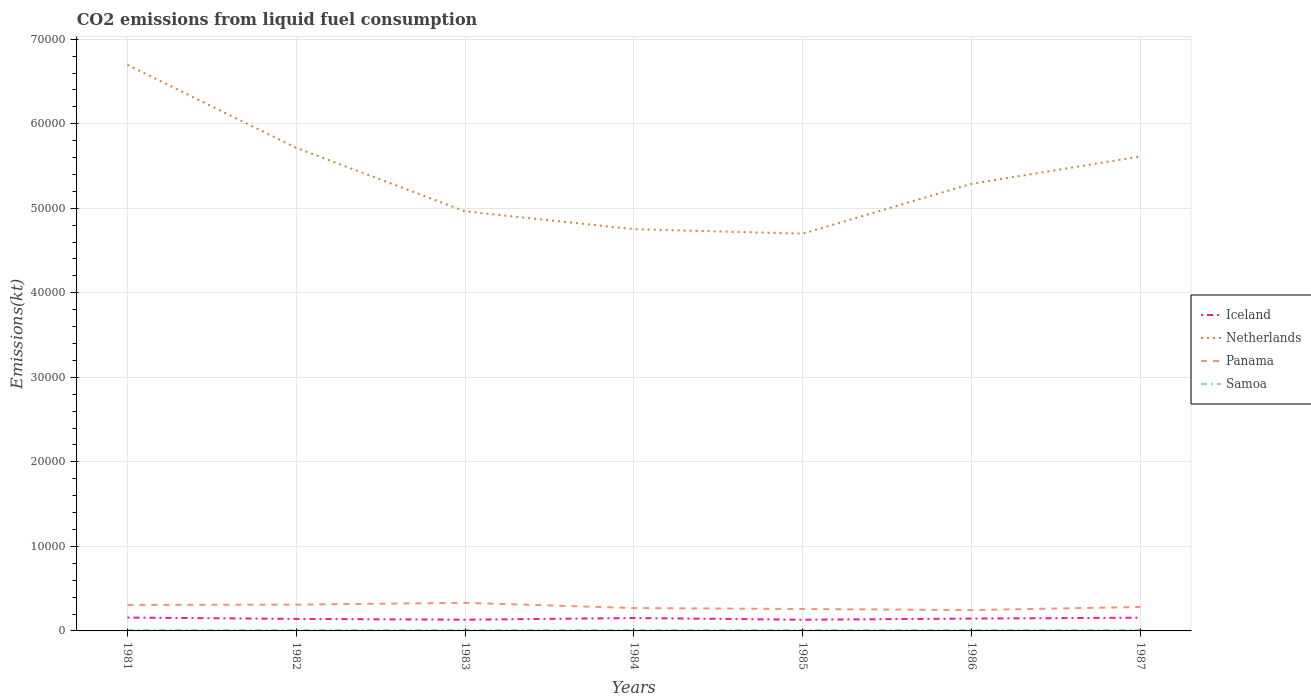How many different coloured lines are there?
Offer a very short reply. 4. Does the line corresponding to Panama intersect with the line corresponding to Netherlands?
Give a very brief answer. No. Is the number of lines equal to the number of legend labels?
Your answer should be compact. Yes. Across all years, what is the maximum amount of CO2 emitted in Panama?
Provide a succinct answer. 2464.22. What is the total amount of CO2 emitted in Netherlands in the graph?
Provide a succinct answer. -3234.29. What is the difference between the highest and the second highest amount of CO2 emitted in Netherlands?
Your answer should be compact. 2.00e+04. How many lines are there?
Provide a short and direct response. 4. Are the values on the major ticks of Y-axis written in scientific E-notation?
Keep it short and to the point. No. Does the graph contain any zero values?
Make the answer very short. No. Does the graph contain grids?
Your answer should be compact. Yes. Where does the legend appear in the graph?
Your answer should be very brief. Center right. How are the legend labels stacked?
Your answer should be compact. Vertical. What is the title of the graph?
Keep it short and to the point. CO2 emissions from liquid fuel consumption. Does "Zambia" appear as one of the legend labels in the graph?
Your answer should be very brief. No. What is the label or title of the Y-axis?
Your answer should be compact. Emissions(kt). What is the Emissions(kt) in Iceland in 1981?
Give a very brief answer. 1580.48. What is the Emissions(kt) of Netherlands in 1981?
Offer a terse response. 6.70e+04. What is the Emissions(kt) in Panama in 1981?
Offer a terse response. 3072.95. What is the Emissions(kt) in Samoa in 1981?
Keep it short and to the point. 102.68. What is the Emissions(kt) of Iceland in 1982?
Make the answer very short. 1422.8. What is the Emissions(kt) of Netherlands in 1982?
Provide a succinct answer. 5.71e+04. What is the Emissions(kt) of Panama in 1982?
Your answer should be very brief. 3109.62. What is the Emissions(kt) of Samoa in 1982?
Offer a very short reply. 113.68. What is the Emissions(kt) of Iceland in 1983?
Keep it short and to the point. 1327.45. What is the Emissions(kt) of Netherlands in 1983?
Your answer should be compact. 4.96e+04. What is the Emissions(kt) in Panama in 1983?
Your answer should be compact. 3325.97. What is the Emissions(kt) of Samoa in 1983?
Your answer should be very brief. 113.68. What is the Emissions(kt) of Iceland in 1984?
Offer a terse response. 1525.47. What is the Emissions(kt) in Netherlands in 1984?
Ensure brevity in your answer.  4.75e+04. What is the Emissions(kt) in Panama in 1984?
Offer a terse response. 2706.25. What is the Emissions(kt) in Samoa in 1984?
Ensure brevity in your answer.  113.68. What is the Emissions(kt) in Iceland in 1985?
Provide a succinct answer. 1323.79. What is the Emissions(kt) in Netherlands in 1985?
Your response must be concise. 4.70e+04. What is the Emissions(kt) of Panama in 1985?
Offer a terse response. 2592.57. What is the Emissions(kt) of Samoa in 1985?
Keep it short and to the point. 113.68. What is the Emissions(kt) in Iceland in 1986?
Provide a succinct answer. 1459.47. What is the Emissions(kt) in Netherlands in 1986?
Provide a succinct answer. 5.29e+04. What is the Emissions(kt) in Panama in 1986?
Give a very brief answer. 2464.22. What is the Emissions(kt) of Samoa in 1986?
Offer a very short reply. 113.68. What is the Emissions(kt) of Iceland in 1987?
Make the answer very short. 1565.81. What is the Emissions(kt) in Netherlands in 1987?
Offer a very short reply. 5.61e+04. What is the Emissions(kt) of Panama in 1987?
Ensure brevity in your answer.  2834.59. What is the Emissions(kt) in Samoa in 1987?
Provide a short and direct response. 113.68. Across all years, what is the maximum Emissions(kt) of Iceland?
Offer a terse response. 1580.48. Across all years, what is the maximum Emissions(kt) of Netherlands?
Give a very brief answer. 6.70e+04. Across all years, what is the maximum Emissions(kt) in Panama?
Your response must be concise. 3325.97. Across all years, what is the maximum Emissions(kt) of Samoa?
Offer a terse response. 113.68. Across all years, what is the minimum Emissions(kt) of Iceland?
Your response must be concise. 1323.79. Across all years, what is the minimum Emissions(kt) of Netherlands?
Your answer should be very brief. 4.70e+04. Across all years, what is the minimum Emissions(kt) in Panama?
Provide a short and direct response. 2464.22. Across all years, what is the minimum Emissions(kt) of Samoa?
Offer a very short reply. 102.68. What is the total Emissions(kt) of Iceland in the graph?
Ensure brevity in your answer.  1.02e+04. What is the total Emissions(kt) of Netherlands in the graph?
Give a very brief answer. 3.77e+05. What is the total Emissions(kt) of Panama in the graph?
Offer a very short reply. 2.01e+04. What is the total Emissions(kt) in Samoa in the graph?
Offer a terse response. 784.74. What is the difference between the Emissions(kt) of Iceland in 1981 and that in 1982?
Keep it short and to the point. 157.68. What is the difference between the Emissions(kt) in Netherlands in 1981 and that in 1982?
Make the answer very short. 9820.23. What is the difference between the Emissions(kt) in Panama in 1981 and that in 1982?
Offer a very short reply. -36.67. What is the difference between the Emissions(kt) of Samoa in 1981 and that in 1982?
Ensure brevity in your answer.  -11. What is the difference between the Emissions(kt) in Iceland in 1981 and that in 1983?
Make the answer very short. 253.02. What is the difference between the Emissions(kt) in Netherlands in 1981 and that in 1983?
Offer a very short reply. 1.73e+04. What is the difference between the Emissions(kt) in Panama in 1981 and that in 1983?
Offer a terse response. -253.02. What is the difference between the Emissions(kt) of Samoa in 1981 and that in 1983?
Keep it short and to the point. -11. What is the difference between the Emissions(kt) in Iceland in 1981 and that in 1984?
Provide a short and direct response. 55.01. What is the difference between the Emissions(kt) of Netherlands in 1981 and that in 1984?
Offer a terse response. 1.94e+04. What is the difference between the Emissions(kt) of Panama in 1981 and that in 1984?
Make the answer very short. 366.7. What is the difference between the Emissions(kt) of Samoa in 1981 and that in 1984?
Your answer should be very brief. -11. What is the difference between the Emissions(kt) of Iceland in 1981 and that in 1985?
Your response must be concise. 256.69. What is the difference between the Emissions(kt) of Netherlands in 1981 and that in 1985?
Your answer should be compact. 2.00e+04. What is the difference between the Emissions(kt) of Panama in 1981 and that in 1985?
Your answer should be compact. 480.38. What is the difference between the Emissions(kt) in Samoa in 1981 and that in 1985?
Your answer should be very brief. -11. What is the difference between the Emissions(kt) in Iceland in 1981 and that in 1986?
Ensure brevity in your answer.  121.01. What is the difference between the Emissions(kt) of Netherlands in 1981 and that in 1986?
Offer a very short reply. 1.41e+04. What is the difference between the Emissions(kt) of Panama in 1981 and that in 1986?
Keep it short and to the point. 608.72. What is the difference between the Emissions(kt) in Samoa in 1981 and that in 1986?
Offer a very short reply. -11. What is the difference between the Emissions(kt) in Iceland in 1981 and that in 1987?
Your answer should be very brief. 14.67. What is the difference between the Emissions(kt) in Netherlands in 1981 and that in 1987?
Your response must be concise. 1.08e+04. What is the difference between the Emissions(kt) in Panama in 1981 and that in 1987?
Provide a succinct answer. 238.35. What is the difference between the Emissions(kt) in Samoa in 1981 and that in 1987?
Offer a very short reply. -11. What is the difference between the Emissions(kt) of Iceland in 1982 and that in 1983?
Your response must be concise. 95.34. What is the difference between the Emissions(kt) of Netherlands in 1982 and that in 1983?
Provide a succinct answer. 7510.02. What is the difference between the Emissions(kt) in Panama in 1982 and that in 1983?
Offer a terse response. -216.35. What is the difference between the Emissions(kt) in Iceland in 1982 and that in 1984?
Offer a very short reply. -102.68. What is the difference between the Emissions(kt) in Netherlands in 1982 and that in 1984?
Give a very brief answer. 9622.21. What is the difference between the Emissions(kt) of Panama in 1982 and that in 1984?
Provide a short and direct response. 403.37. What is the difference between the Emissions(kt) in Iceland in 1982 and that in 1985?
Make the answer very short. 99.01. What is the difference between the Emissions(kt) of Netherlands in 1982 and that in 1985?
Your response must be concise. 1.02e+04. What is the difference between the Emissions(kt) in Panama in 1982 and that in 1985?
Your response must be concise. 517.05. What is the difference between the Emissions(kt) in Samoa in 1982 and that in 1985?
Your answer should be very brief. 0. What is the difference between the Emissions(kt) in Iceland in 1982 and that in 1986?
Your answer should be compact. -36.67. What is the difference between the Emissions(kt) of Netherlands in 1982 and that in 1986?
Give a very brief answer. 4253.72. What is the difference between the Emissions(kt) in Panama in 1982 and that in 1986?
Ensure brevity in your answer.  645.39. What is the difference between the Emissions(kt) of Iceland in 1982 and that in 1987?
Your answer should be very brief. -143.01. What is the difference between the Emissions(kt) of Netherlands in 1982 and that in 1987?
Ensure brevity in your answer.  1019.43. What is the difference between the Emissions(kt) of Panama in 1982 and that in 1987?
Make the answer very short. 275.02. What is the difference between the Emissions(kt) in Iceland in 1983 and that in 1984?
Provide a short and direct response. -198.02. What is the difference between the Emissions(kt) of Netherlands in 1983 and that in 1984?
Your response must be concise. 2112.19. What is the difference between the Emissions(kt) of Panama in 1983 and that in 1984?
Make the answer very short. 619.72. What is the difference between the Emissions(kt) of Samoa in 1983 and that in 1984?
Provide a short and direct response. 0. What is the difference between the Emissions(kt) of Iceland in 1983 and that in 1985?
Keep it short and to the point. 3.67. What is the difference between the Emissions(kt) in Netherlands in 1983 and that in 1985?
Provide a succinct answer. 2640.24. What is the difference between the Emissions(kt) in Panama in 1983 and that in 1985?
Offer a very short reply. 733.4. What is the difference between the Emissions(kt) in Samoa in 1983 and that in 1985?
Provide a short and direct response. 0. What is the difference between the Emissions(kt) in Iceland in 1983 and that in 1986?
Ensure brevity in your answer.  -132.01. What is the difference between the Emissions(kt) of Netherlands in 1983 and that in 1986?
Your answer should be very brief. -3256.3. What is the difference between the Emissions(kt) in Panama in 1983 and that in 1986?
Ensure brevity in your answer.  861.75. What is the difference between the Emissions(kt) of Iceland in 1983 and that in 1987?
Make the answer very short. -238.35. What is the difference between the Emissions(kt) in Netherlands in 1983 and that in 1987?
Your response must be concise. -6490.59. What is the difference between the Emissions(kt) of Panama in 1983 and that in 1987?
Offer a terse response. 491.38. What is the difference between the Emissions(kt) in Samoa in 1983 and that in 1987?
Your answer should be compact. 0. What is the difference between the Emissions(kt) in Iceland in 1984 and that in 1985?
Offer a terse response. 201.69. What is the difference between the Emissions(kt) in Netherlands in 1984 and that in 1985?
Your answer should be compact. 528.05. What is the difference between the Emissions(kt) in Panama in 1984 and that in 1985?
Offer a very short reply. 113.68. What is the difference between the Emissions(kt) of Samoa in 1984 and that in 1985?
Your answer should be compact. 0. What is the difference between the Emissions(kt) in Iceland in 1984 and that in 1986?
Ensure brevity in your answer.  66.01. What is the difference between the Emissions(kt) in Netherlands in 1984 and that in 1986?
Provide a succinct answer. -5368.49. What is the difference between the Emissions(kt) in Panama in 1984 and that in 1986?
Your answer should be compact. 242.02. What is the difference between the Emissions(kt) of Samoa in 1984 and that in 1986?
Offer a terse response. 0. What is the difference between the Emissions(kt) in Iceland in 1984 and that in 1987?
Give a very brief answer. -40.34. What is the difference between the Emissions(kt) in Netherlands in 1984 and that in 1987?
Make the answer very short. -8602.78. What is the difference between the Emissions(kt) in Panama in 1984 and that in 1987?
Your answer should be compact. -128.34. What is the difference between the Emissions(kt) in Samoa in 1984 and that in 1987?
Ensure brevity in your answer.  0. What is the difference between the Emissions(kt) in Iceland in 1985 and that in 1986?
Provide a short and direct response. -135.68. What is the difference between the Emissions(kt) in Netherlands in 1985 and that in 1986?
Offer a very short reply. -5896.54. What is the difference between the Emissions(kt) in Panama in 1985 and that in 1986?
Ensure brevity in your answer.  128.34. What is the difference between the Emissions(kt) of Iceland in 1985 and that in 1987?
Keep it short and to the point. -242.02. What is the difference between the Emissions(kt) of Netherlands in 1985 and that in 1987?
Your response must be concise. -9130.83. What is the difference between the Emissions(kt) of Panama in 1985 and that in 1987?
Keep it short and to the point. -242.02. What is the difference between the Emissions(kt) of Iceland in 1986 and that in 1987?
Your answer should be compact. -106.34. What is the difference between the Emissions(kt) in Netherlands in 1986 and that in 1987?
Your response must be concise. -3234.29. What is the difference between the Emissions(kt) of Panama in 1986 and that in 1987?
Your response must be concise. -370.37. What is the difference between the Emissions(kt) of Samoa in 1986 and that in 1987?
Make the answer very short. 0. What is the difference between the Emissions(kt) of Iceland in 1981 and the Emissions(kt) of Netherlands in 1982?
Your answer should be very brief. -5.56e+04. What is the difference between the Emissions(kt) of Iceland in 1981 and the Emissions(kt) of Panama in 1982?
Keep it short and to the point. -1529.14. What is the difference between the Emissions(kt) in Iceland in 1981 and the Emissions(kt) in Samoa in 1982?
Offer a terse response. 1466.8. What is the difference between the Emissions(kt) of Netherlands in 1981 and the Emissions(kt) of Panama in 1982?
Keep it short and to the point. 6.39e+04. What is the difference between the Emissions(kt) of Netherlands in 1981 and the Emissions(kt) of Samoa in 1982?
Provide a succinct answer. 6.69e+04. What is the difference between the Emissions(kt) of Panama in 1981 and the Emissions(kt) of Samoa in 1982?
Offer a terse response. 2959.27. What is the difference between the Emissions(kt) of Iceland in 1981 and the Emissions(kt) of Netherlands in 1983?
Ensure brevity in your answer.  -4.81e+04. What is the difference between the Emissions(kt) in Iceland in 1981 and the Emissions(kt) in Panama in 1983?
Make the answer very short. -1745.49. What is the difference between the Emissions(kt) in Iceland in 1981 and the Emissions(kt) in Samoa in 1983?
Ensure brevity in your answer.  1466.8. What is the difference between the Emissions(kt) of Netherlands in 1981 and the Emissions(kt) of Panama in 1983?
Your answer should be very brief. 6.36e+04. What is the difference between the Emissions(kt) of Netherlands in 1981 and the Emissions(kt) of Samoa in 1983?
Ensure brevity in your answer.  6.69e+04. What is the difference between the Emissions(kt) in Panama in 1981 and the Emissions(kt) in Samoa in 1983?
Ensure brevity in your answer.  2959.27. What is the difference between the Emissions(kt) in Iceland in 1981 and the Emissions(kt) in Netherlands in 1984?
Give a very brief answer. -4.59e+04. What is the difference between the Emissions(kt) of Iceland in 1981 and the Emissions(kt) of Panama in 1984?
Ensure brevity in your answer.  -1125.77. What is the difference between the Emissions(kt) in Iceland in 1981 and the Emissions(kt) in Samoa in 1984?
Ensure brevity in your answer.  1466.8. What is the difference between the Emissions(kt) in Netherlands in 1981 and the Emissions(kt) in Panama in 1984?
Offer a terse response. 6.43e+04. What is the difference between the Emissions(kt) in Netherlands in 1981 and the Emissions(kt) in Samoa in 1984?
Offer a terse response. 6.69e+04. What is the difference between the Emissions(kt) of Panama in 1981 and the Emissions(kt) of Samoa in 1984?
Offer a very short reply. 2959.27. What is the difference between the Emissions(kt) in Iceland in 1981 and the Emissions(kt) in Netherlands in 1985?
Keep it short and to the point. -4.54e+04. What is the difference between the Emissions(kt) of Iceland in 1981 and the Emissions(kt) of Panama in 1985?
Provide a succinct answer. -1012.09. What is the difference between the Emissions(kt) in Iceland in 1981 and the Emissions(kt) in Samoa in 1985?
Give a very brief answer. 1466.8. What is the difference between the Emissions(kt) of Netherlands in 1981 and the Emissions(kt) of Panama in 1985?
Provide a succinct answer. 6.44e+04. What is the difference between the Emissions(kt) in Netherlands in 1981 and the Emissions(kt) in Samoa in 1985?
Give a very brief answer. 6.69e+04. What is the difference between the Emissions(kt) in Panama in 1981 and the Emissions(kt) in Samoa in 1985?
Make the answer very short. 2959.27. What is the difference between the Emissions(kt) of Iceland in 1981 and the Emissions(kt) of Netherlands in 1986?
Your answer should be very brief. -5.13e+04. What is the difference between the Emissions(kt) in Iceland in 1981 and the Emissions(kt) in Panama in 1986?
Offer a terse response. -883.75. What is the difference between the Emissions(kt) of Iceland in 1981 and the Emissions(kt) of Samoa in 1986?
Provide a short and direct response. 1466.8. What is the difference between the Emissions(kt) in Netherlands in 1981 and the Emissions(kt) in Panama in 1986?
Your answer should be very brief. 6.45e+04. What is the difference between the Emissions(kt) in Netherlands in 1981 and the Emissions(kt) in Samoa in 1986?
Make the answer very short. 6.69e+04. What is the difference between the Emissions(kt) of Panama in 1981 and the Emissions(kt) of Samoa in 1986?
Ensure brevity in your answer.  2959.27. What is the difference between the Emissions(kt) in Iceland in 1981 and the Emissions(kt) in Netherlands in 1987?
Provide a succinct answer. -5.45e+04. What is the difference between the Emissions(kt) of Iceland in 1981 and the Emissions(kt) of Panama in 1987?
Your answer should be very brief. -1254.11. What is the difference between the Emissions(kt) in Iceland in 1981 and the Emissions(kt) in Samoa in 1987?
Provide a succinct answer. 1466.8. What is the difference between the Emissions(kt) of Netherlands in 1981 and the Emissions(kt) of Panama in 1987?
Your answer should be compact. 6.41e+04. What is the difference between the Emissions(kt) in Netherlands in 1981 and the Emissions(kt) in Samoa in 1987?
Keep it short and to the point. 6.69e+04. What is the difference between the Emissions(kt) in Panama in 1981 and the Emissions(kt) in Samoa in 1987?
Give a very brief answer. 2959.27. What is the difference between the Emissions(kt) of Iceland in 1982 and the Emissions(kt) of Netherlands in 1983?
Provide a succinct answer. -4.82e+04. What is the difference between the Emissions(kt) of Iceland in 1982 and the Emissions(kt) of Panama in 1983?
Provide a succinct answer. -1903.17. What is the difference between the Emissions(kt) in Iceland in 1982 and the Emissions(kt) in Samoa in 1983?
Your answer should be very brief. 1309.12. What is the difference between the Emissions(kt) of Netherlands in 1982 and the Emissions(kt) of Panama in 1983?
Make the answer very short. 5.38e+04. What is the difference between the Emissions(kt) in Netherlands in 1982 and the Emissions(kt) in Samoa in 1983?
Provide a short and direct response. 5.70e+04. What is the difference between the Emissions(kt) in Panama in 1982 and the Emissions(kt) in Samoa in 1983?
Make the answer very short. 2995.94. What is the difference between the Emissions(kt) of Iceland in 1982 and the Emissions(kt) of Netherlands in 1984?
Your response must be concise. -4.61e+04. What is the difference between the Emissions(kt) in Iceland in 1982 and the Emissions(kt) in Panama in 1984?
Keep it short and to the point. -1283.45. What is the difference between the Emissions(kt) in Iceland in 1982 and the Emissions(kt) in Samoa in 1984?
Provide a short and direct response. 1309.12. What is the difference between the Emissions(kt) in Netherlands in 1982 and the Emissions(kt) in Panama in 1984?
Give a very brief answer. 5.44e+04. What is the difference between the Emissions(kt) in Netherlands in 1982 and the Emissions(kt) in Samoa in 1984?
Provide a short and direct response. 5.70e+04. What is the difference between the Emissions(kt) in Panama in 1982 and the Emissions(kt) in Samoa in 1984?
Make the answer very short. 2995.94. What is the difference between the Emissions(kt) in Iceland in 1982 and the Emissions(kt) in Netherlands in 1985?
Your answer should be compact. -4.56e+04. What is the difference between the Emissions(kt) of Iceland in 1982 and the Emissions(kt) of Panama in 1985?
Provide a succinct answer. -1169.77. What is the difference between the Emissions(kt) in Iceland in 1982 and the Emissions(kt) in Samoa in 1985?
Offer a very short reply. 1309.12. What is the difference between the Emissions(kt) in Netherlands in 1982 and the Emissions(kt) in Panama in 1985?
Make the answer very short. 5.46e+04. What is the difference between the Emissions(kt) in Netherlands in 1982 and the Emissions(kt) in Samoa in 1985?
Offer a terse response. 5.70e+04. What is the difference between the Emissions(kt) in Panama in 1982 and the Emissions(kt) in Samoa in 1985?
Keep it short and to the point. 2995.94. What is the difference between the Emissions(kt) in Iceland in 1982 and the Emissions(kt) in Netherlands in 1986?
Your answer should be very brief. -5.15e+04. What is the difference between the Emissions(kt) of Iceland in 1982 and the Emissions(kt) of Panama in 1986?
Ensure brevity in your answer.  -1041.43. What is the difference between the Emissions(kt) of Iceland in 1982 and the Emissions(kt) of Samoa in 1986?
Your answer should be compact. 1309.12. What is the difference between the Emissions(kt) in Netherlands in 1982 and the Emissions(kt) in Panama in 1986?
Your answer should be compact. 5.47e+04. What is the difference between the Emissions(kt) of Netherlands in 1982 and the Emissions(kt) of Samoa in 1986?
Provide a succinct answer. 5.70e+04. What is the difference between the Emissions(kt) of Panama in 1982 and the Emissions(kt) of Samoa in 1986?
Your response must be concise. 2995.94. What is the difference between the Emissions(kt) in Iceland in 1982 and the Emissions(kt) in Netherlands in 1987?
Your answer should be very brief. -5.47e+04. What is the difference between the Emissions(kt) in Iceland in 1982 and the Emissions(kt) in Panama in 1987?
Your answer should be compact. -1411.8. What is the difference between the Emissions(kt) in Iceland in 1982 and the Emissions(kt) in Samoa in 1987?
Your answer should be very brief. 1309.12. What is the difference between the Emissions(kt) of Netherlands in 1982 and the Emissions(kt) of Panama in 1987?
Provide a succinct answer. 5.43e+04. What is the difference between the Emissions(kt) in Netherlands in 1982 and the Emissions(kt) in Samoa in 1987?
Your answer should be very brief. 5.70e+04. What is the difference between the Emissions(kt) of Panama in 1982 and the Emissions(kt) of Samoa in 1987?
Provide a short and direct response. 2995.94. What is the difference between the Emissions(kt) in Iceland in 1983 and the Emissions(kt) in Netherlands in 1984?
Make the answer very short. -4.62e+04. What is the difference between the Emissions(kt) of Iceland in 1983 and the Emissions(kt) of Panama in 1984?
Provide a short and direct response. -1378.79. What is the difference between the Emissions(kt) of Iceland in 1983 and the Emissions(kt) of Samoa in 1984?
Your answer should be very brief. 1213.78. What is the difference between the Emissions(kt) of Netherlands in 1983 and the Emissions(kt) of Panama in 1984?
Make the answer very short. 4.69e+04. What is the difference between the Emissions(kt) in Netherlands in 1983 and the Emissions(kt) in Samoa in 1984?
Provide a succinct answer. 4.95e+04. What is the difference between the Emissions(kt) of Panama in 1983 and the Emissions(kt) of Samoa in 1984?
Your response must be concise. 3212.29. What is the difference between the Emissions(kt) of Iceland in 1983 and the Emissions(kt) of Netherlands in 1985?
Keep it short and to the point. -4.57e+04. What is the difference between the Emissions(kt) in Iceland in 1983 and the Emissions(kt) in Panama in 1985?
Provide a short and direct response. -1265.12. What is the difference between the Emissions(kt) of Iceland in 1983 and the Emissions(kt) of Samoa in 1985?
Make the answer very short. 1213.78. What is the difference between the Emissions(kt) in Netherlands in 1983 and the Emissions(kt) in Panama in 1985?
Make the answer very short. 4.70e+04. What is the difference between the Emissions(kt) in Netherlands in 1983 and the Emissions(kt) in Samoa in 1985?
Keep it short and to the point. 4.95e+04. What is the difference between the Emissions(kt) of Panama in 1983 and the Emissions(kt) of Samoa in 1985?
Make the answer very short. 3212.29. What is the difference between the Emissions(kt) of Iceland in 1983 and the Emissions(kt) of Netherlands in 1986?
Ensure brevity in your answer.  -5.16e+04. What is the difference between the Emissions(kt) in Iceland in 1983 and the Emissions(kt) in Panama in 1986?
Ensure brevity in your answer.  -1136.77. What is the difference between the Emissions(kt) in Iceland in 1983 and the Emissions(kt) in Samoa in 1986?
Your answer should be compact. 1213.78. What is the difference between the Emissions(kt) in Netherlands in 1983 and the Emissions(kt) in Panama in 1986?
Your answer should be compact. 4.72e+04. What is the difference between the Emissions(kt) of Netherlands in 1983 and the Emissions(kt) of Samoa in 1986?
Your answer should be compact. 4.95e+04. What is the difference between the Emissions(kt) in Panama in 1983 and the Emissions(kt) in Samoa in 1986?
Your response must be concise. 3212.29. What is the difference between the Emissions(kt) in Iceland in 1983 and the Emissions(kt) in Netherlands in 1987?
Ensure brevity in your answer.  -5.48e+04. What is the difference between the Emissions(kt) of Iceland in 1983 and the Emissions(kt) of Panama in 1987?
Offer a terse response. -1507.14. What is the difference between the Emissions(kt) in Iceland in 1983 and the Emissions(kt) in Samoa in 1987?
Provide a short and direct response. 1213.78. What is the difference between the Emissions(kt) in Netherlands in 1983 and the Emissions(kt) in Panama in 1987?
Keep it short and to the point. 4.68e+04. What is the difference between the Emissions(kt) in Netherlands in 1983 and the Emissions(kt) in Samoa in 1987?
Your response must be concise. 4.95e+04. What is the difference between the Emissions(kt) of Panama in 1983 and the Emissions(kt) of Samoa in 1987?
Offer a very short reply. 3212.29. What is the difference between the Emissions(kt) of Iceland in 1984 and the Emissions(kt) of Netherlands in 1985?
Offer a very short reply. -4.55e+04. What is the difference between the Emissions(kt) in Iceland in 1984 and the Emissions(kt) in Panama in 1985?
Ensure brevity in your answer.  -1067.1. What is the difference between the Emissions(kt) in Iceland in 1984 and the Emissions(kt) in Samoa in 1985?
Your answer should be compact. 1411.8. What is the difference between the Emissions(kt) in Netherlands in 1984 and the Emissions(kt) in Panama in 1985?
Keep it short and to the point. 4.49e+04. What is the difference between the Emissions(kt) in Netherlands in 1984 and the Emissions(kt) in Samoa in 1985?
Your answer should be compact. 4.74e+04. What is the difference between the Emissions(kt) in Panama in 1984 and the Emissions(kt) in Samoa in 1985?
Offer a terse response. 2592.57. What is the difference between the Emissions(kt) of Iceland in 1984 and the Emissions(kt) of Netherlands in 1986?
Give a very brief answer. -5.14e+04. What is the difference between the Emissions(kt) in Iceland in 1984 and the Emissions(kt) in Panama in 1986?
Ensure brevity in your answer.  -938.75. What is the difference between the Emissions(kt) in Iceland in 1984 and the Emissions(kt) in Samoa in 1986?
Your answer should be compact. 1411.8. What is the difference between the Emissions(kt) of Netherlands in 1984 and the Emissions(kt) of Panama in 1986?
Offer a terse response. 4.51e+04. What is the difference between the Emissions(kt) of Netherlands in 1984 and the Emissions(kt) of Samoa in 1986?
Offer a very short reply. 4.74e+04. What is the difference between the Emissions(kt) in Panama in 1984 and the Emissions(kt) in Samoa in 1986?
Ensure brevity in your answer.  2592.57. What is the difference between the Emissions(kt) in Iceland in 1984 and the Emissions(kt) in Netherlands in 1987?
Your answer should be compact. -5.46e+04. What is the difference between the Emissions(kt) in Iceland in 1984 and the Emissions(kt) in Panama in 1987?
Provide a succinct answer. -1309.12. What is the difference between the Emissions(kt) of Iceland in 1984 and the Emissions(kt) of Samoa in 1987?
Your response must be concise. 1411.8. What is the difference between the Emissions(kt) in Netherlands in 1984 and the Emissions(kt) in Panama in 1987?
Offer a terse response. 4.47e+04. What is the difference between the Emissions(kt) in Netherlands in 1984 and the Emissions(kt) in Samoa in 1987?
Provide a succinct answer. 4.74e+04. What is the difference between the Emissions(kt) in Panama in 1984 and the Emissions(kt) in Samoa in 1987?
Offer a very short reply. 2592.57. What is the difference between the Emissions(kt) of Iceland in 1985 and the Emissions(kt) of Netherlands in 1986?
Make the answer very short. -5.16e+04. What is the difference between the Emissions(kt) of Iceland in 1985 and the Emissions(kt) of Panama in 1986?
Your answer should be compact. -1140.44. What is the difference between the Emissions(kt) in Iceland in 1985 and the Emissions(kt) in Samoa in 1986?
Provide a succinct answer. 1210.11. What is the difference between the Emissions(kt) of Netherlands in 1985 and the Emissions(kt) of Panama in 1986?
Ensure brevity in your answer.  4.45e+04. What is the difference between the Emissions(kt) of Netherlands in 1985 and the Emissions(kt) of Samoa in 1986?
Provide a succinct answer. 4.69e+04. What is the difference between the Emissions(kt) in Panama in 1985 and the Emissions(kt) in Samoa in 1986?
Make the answer very short. 2478.89. What is the difference between the Emissions(kt) of Iceland in 1985 and the Emissions(kt) of Netherlands in 1987?
Your answer should be very brief. -5.48e+04. What is the difference between the Emissions(kt) in Iceland in 1985 and the Emissions(kt) in Panama in 1987?
Keep it short and to the point. -1510.8. What is the difference between the Emissions(kt) of Iceland in 1985 and the Emissions(kt) of Samoa in 1987?
Make the answer very short. 1210.11. What is the difference between the Emissions(kt) of Netherlands in 1985 and the Emissions(kt) of Panama in 1987?
Offer a very short reply. 4.42e+04. What is the difference between the Emissions(kt) in Netherlands in 1985 and the Emissions(kt) in Samoa in 1987?
Ensure brevity in your answer.  4.69e+04. What is the difference between the Emissions(kt) of Panama in 1985 and the Emissions(kt) of Samoa in 1987?
Your answer should be compact. 2478.89. What is the difference between the Emissions(kt) of Iceland in 1986 and the Emissions(kt) of Netherlands in 1987?
Your response must be concise. -5.47e+04. What is the difference between the Emissions(kt) in Iceland in 1986 and the Emissions(kt) in Panama in 1987?
Provide a short and direct response. -1375.12. What is the difference between the Emissions(kt) of Iceland in 1986 and the Emissions(kt) of Samoa in 1987?
Give a very brief answer. 1345.79. What is the difference between the Emissions(kt) of Netherlands in 1986 and the Emissions(kt) of Panama in 1987?
Your answer should be compact. 5.01e+04. What is the difference between the Emissions(kt) of Netherlands in 1986 and the Emissions(kt) of Samoa in 1987?
Give a very brief answer. 5.28e+04. What is the difference between the Emissions(kt) in Panama in 1986 and the Emissions(kt) in Samoa in 1987?
Ensure brevity in your answer.  2350.55. What is the average Emissions(kt) in Iceland per year?
Offer a very short reply. 1457.89. What is the average Emissions(kt) of Netherlands per year?
Provide a succinct answer. 5.39e+04. What is the average Emissions(kt) in Panama per year?
Your answer should be very brief. 2872.31. What is the average Emissions(kt) of Samoa per year?
Your response must be concise. 112.11. In the year 1981, what is the difference between the Emissions(kt) in Iceland and Emissions(kt) in Netherlands?
Offer a terse response. -6.54e+04. In the year 1981, what is the difference between the Emissions(kt) of Iceland and Emissions(kt) of Panama?
Your answer should be very brief. -1492.47. In the year 1981, what is the difference between the Emissions(kt) in Iceland and Emissions(kt) in Samoa?
Make the answer very short. 1477.8. In the year 1981, what is the difference between the Emissions(kt) in Netherlands and Emissions(kt) in Panama?
Keep it short and to the point. 6.39e+04. In the year 1981, what is the difference between the Emissions(kt) of Netherlands and Emissions(kt) of Samoa?
Make the answer very short. 6.69e+04. In the year 1981, what is the difference between the Emissions(kt) of Panama and Emissions(kt) of Samoa?
Provide a short and direct response. 2970.27. In the year 1982, what is the difference between the Emissions(kt) in Iceland and Emissions(kt) in Netherlands?
Ensure brevity in your answer.  -5.57e+04. In the year 1982, what is the difference between the Emissions(kt) of Iceland and Emissions(kt) of Panama?
Your answer should be very brief. -1686.82. In the year 1982, what is the difference between the Emissions(kt) of Iceland and Emissions(kt) of Samoa?
Give a very brief answer. 1309.12. In the year 1982, what is the difference between the Emissions(kt) in Netherlands and Emissions(kt) in Panama?
Keep it short and to the point. 5.40e+04. In the year 1982, what is the difference between the Emissions(kt) of Netherlands and Emissions(kt) of Samoa?
Your response must be concise. 5.70e+04. In the year 1982, what is the difference between the Emissions(kt) in Panama and Emissions(kt) in Samoa?
Your response must be concise. 2995.94. In the year 1983, what is the difference between the Emissions(kt) of Iceland and Emissions(kt) of Netherlands?
Your response must be concise. -4.83e+04. In the year 1983, what is the difference between the Emissions(kt) of Iceland and Emissions(kt) of Panama?
Provide a succinct answer. -1998.52. In the year 1983, what is the difference between the Emissions(kt) in Iceland and Emissions(kt) in Samoa?
Provide a short and direct response. 1213.78. In the year 1983, what is the difference between the Emissions(kt) of Netherlands and Emissions(kt) of Panama?
Keep it short and to the point. 4.63e+04. In the year 1983, what is the difference between the Emissions(kt) of Netherlands and Emissions(kt) of Samoa?
Provide a succinct answer. 4.95e+04. In the year 1983, what is the difference between the Emissions(kt) of Panama and Emissions(kt) of Samoa?
Your answer should be compact. 3212.29. In the year 1984, what is the difference between the Emissions(kt) in Iceland and Emissions(kt) in Netherlands?
Make the answer very short. -4.60e+04. In the year 1984, what is the difference between the Emissions(kt) of Iceland and Emissions(kt) of Panama?
Offer a terse response. -1180.77. In the year 1984, what is the difference between the Emissions(kt) of Iceland and Emissions(kt) of Samoa?
Keep it short and to the point. 1411.8. In the year 1984, what is the difference between the Emissions(kt) of Netherlands and Emissions(kt) of Panama?
Keep it short and to the point. 4.48e+04. In the year 1984, what is the difference between the Emissions(kt) of Netherlands and Emissions(kt) of Samoa?
Your response must be concise. 4.74e+04. In the year 1984, what is the difference between the Emissions(kt) of Panama and Emissions(kt) of Samoa?
Your answer should be compact. 2592.57. In the year 1985, what is the difference between the Emissions(kt) in Iceland and Emissions(kt) in Netherlands?
Offer a very short reply. -4.57e+04. In the year 1985, what is the difference between the Emissions(kt) of Iceland and Emissions(kt) of Panama?
Your response must be concise. -1268.78. In the year 1985, what is the difference between the Emissions(kt) in Iceland and Emissions(kt) in Samoa?
Offer a terse response. 1210.11. In the year 1985, what is the difference between the Emissions(kt) of Netherlands and Emissions(kt) of Panama?
Provide a short and direct response. 4.44e+04. In the year 1985, what is the difference between the Emissions(kt) in Netherlands and Emissions(kt) in Samoa?
Your response must be concise. 4.69e+04. In the year 1985, what is the difference between the Emissions(kt) in Panama and Emissions(kt) in Samoa?
Your answer should be compact. 2478.89. In the year 1986, what is the difference between the Emissions(kt) in Iceland and Emissions(kt) in Netherlands?
Make the answer very short. -5.14e+04. In the year 1986, what is the difference between the Emissions(kt) in Iceland and Emissions(kt) in Panama?
Provide a succinct answer. -1004.76. In the year 1986, what is the difference between the Emissions(kt) in Iceland and Emissions(kt) in Samoa?
Offer a very short reply. 1345.79. In the year 1986, what is the difference between the Emissions(kt) in Netherlands and Emissions(kt) in Panama?
Provide a short and direct response. 5.04e+04. In the year 1986, what is the difference between the Emissions(kt) in Netherlands and Emissions(kt) in Samoa?
Your response must be concise. 5.28e+04. In the year 1986, what is the difference between the Emissions(kt) in Panama and Emissions(kt) in Samoa?
Your response must be concise. 2350.55. In the year 1987, what is the difference between the Emissions(kt) in Iceland and Emissions(kt) in Netherlands?
Make the answer very short. -5.46e+04. In the year 1987, what is the difference between the Emissions(kt) in Iceland and Emissions(kt) in Panama?
Offer a terse response. -1268.78. In the year 1987, what is the difference between the Emissions(kt) of Iceland and Emissions(kt) of Samoa?
Provide a short and direct response. 1452.13. In the year 1987, what is the difference between the Emissions(kt) in Netherlands and Emissions(kt) in Panama?
Provide a short and direct response. 5.33e+04. In the year 1987, what is the difference between the Emissions(kt) in Netherlands and Emissions(kt) in Samoa?
Ensure brevity in your answer.  5.60e+04. In the year 1987, what is the difference between the Emissions(kt) in Panama and Emissions(kt) in Samoa?
Make the answer very short. 2720.91. What is the ratio of the Emissions(kt) of Iceland in 1981 to that in 1982?
Provide a short and direct response. 1.11. What is the ratio of the Emissions(kt) in Netherlands in 1981 to that in 1982?
Your response must be concise. 1.17. What is the ratio of the Emissions(kt) of Panama in 1981 to that in 1982?
Ensure brevity in your answer.  0.99. What is the ratio of the Emissions(kt) of Samoa in 1981 to that in 1982?
Provide a succinct answer. 0.9. What is the ratio of the Emissions(kt) in Iceland in 1981 to that in 1983?
Provide a short and direct response. 1.19. What is the ratio of the Emissions(kt) in Netherlands in 1981 to that in 1983?
Ensure brevity in your answer.  1.35. What is the ratio of the Emissions(kt) in Panama in 1981 to that in 1983?
Make the answer very short. 0.92. What is the ratio of the Emissions(kt) of Samoa in 1981 to that in 1983?
Provide a short and direct response. 0.9. What is the ratio of the Emissions(kt) of Iceland in 1981 to that in 1984?
Offer a very short reply. 1.04. What is the ratio of the Emissions(kt) of Netherlands in 1981 to that in 1984?
Your answer should be compact. 1.41. What is the ratio of the Emissions(kt) of Panama in 1981 to that in 1984?
Ensure brevity in your answer.  1.14. What is the ratio of the Emissions(kt) in Samoa in 1981 to that in 1984?
Your response must be concise. 0.9. What is the ratio of the Emissions(kt) in Iceland in 1981 to that in 1985?
Make the answer very short. 1.19. What is the ratio of the Emissions(kt) of Netherlands in 1981 to that in 1985?
Provide a short and direct response. 1.42. What is the ratio of the Emissions(kt) in Panama in 1981 to that in 1985?
Your answer should be compact. 1.19. What is the ratio of the Emissions(kt) of Samoa in 1981 to that in 1985?
Offer a very short reply. 0.9. What is the ratio of the Emissions(kt) in Iceland in 1981 to that in 1986?
Give a very brief answer. 1.08. What is the ratio of the Emissions(kt) of Netherlands in 1981 to that in 1986?
Make the answer very short. 1.27. What is the ratio of the Emissions(kt) in Panama in 1981 to that in 1986?
Provide a short and direct response. 1.25. What is the ratio of the Emissions(kt) of Samoa in 1981 to that in 1986?
Make the answer very short. 0.9. What is the ratio of the Emissions(kt) of Iceland in 1981 to that in 1987?
Provide a short and direct response. 1.01. What is the ratio of the Emissions(kt) of Netherlands in 1981 to that in 1987?
Offer a very short reply. 1.19. What is the ratio of the Emissions(kt) in Panama in 1981 to that in 1987?
Your answer should be very brief. 1.08. What is the ratio of the Emissions(kt) in Samoa in 1981 to that in 1987?
Your response must be concise. 0.9. What is the ratio of the Emissions(kt) in Iceland in 1982 to that in 1983?
Your response must be concise. 1.07. What is the ratio of the Emissions(kt) in Netherlands in 1982 to that in 1983?
Your answer should be very brief. 1.15. What is the ratio of the Emissions(kt) in Panama in 1982 to that in 1983?
Make the answer very short. 0.94. What is the ratio of the Emissions(kt) in Samoa in 1982 to that in 1983?
Offer a terse response. 1. What is the ratio of the Emissions(kt) of Iceland in 1982 to that in 1984?
Ensure brevity in your answer.  0.93. What is the ratio of the Emissions(kt) of Netherlands in 1982 to that in 1984?
Your response must be concise. 1.2. What is the ratio of the Emissions(kt) in Panama in 1982 to that in 1984?
Make the answer very short. 1.15. What is the ratio of the Emissions(kt) of Samoa in 1982 to that in 1984?
Keep it short and to the point. 1. What is the ratio of the Emissions(kt) of Iceland in 1982 to that in 1985?
Ensure brevity in your answer.  1.07. What is the ratio of the Emissions(kt) in Netherlands in 1982 to that in 1985?
Provide a succinct answer. 1.22. What is the ratio of the Emissions(kt) of Panama in 1982 to that in 1985?
Your answer should be compact. 1.2. What is the ratio of the Emissions(kt) of Iceland in 1982 to that in 1986?
Provide a succinct answer. 0.97. What is the ratio of the Emissions(kt) in Netherlands in 1982 to that in 1986?
Your answer should be compact. 1.08. What is the ratio of the Emissions(kt) of Panama in 1982 to that in 1986?
Offer a terse response. 1.26. What is the ratio of the Emissions(kt) in Iceland in 1982 to that in 1987?
Give a very brief answer. 0.91. What is the ratio of the Emissions(kt) of Netherlands in 1982 to that in 1987?
Ensure brevity in your answer.  1.02. What is the ratio of the Emissions(kt) of Panama in 1982 to that in 1987?
Keep it short and to the point. 1.1. What is the ratio of the Emissions(kt) of Iceland in 1983 to that in 1984?
Provide a succinct answer. 0.87. What is the ratio of the Emissions(kt) of Netherlands in 1983 to that in 1984?
Offer a terse response. 1.04. What is the ratio of the Emissions(kt) of Panama in 1983 to that in 1984?
Your answer should be very brief. 1.23. What is the ratio of the Emissions(kt) of Samoa in 1983 to that in 1984?
Your answer should be very brief. 1. What is the ratio of the Emissions(kt) of Iceland in 1983 to that in 1985?
Ensure brevity in your answer.  1. What is the ratio of the Emissions(kt) in Netherlands in 1983 to that in 1985?
Your answer should be very brief. 1.06. What is the ratio of the Emissions(kt) in Panama in 1983 to that in 1985?
Give a very brief answer. 1.28. What is the ratio of the Emissions(kt) of Samoa in 1983 to that in 1985?
Your answer should be compact. 1. What is the ratio of the Emissions(kt) of Iceland in 1983 to that in 1986?
Provide a short and direct response. 0.91. What is the ratio of the Emissions(kt) in Netherlands in 1983 to that in 1986?
Give a very brief answer. 0.94. What is the ratio of the Emissions(kt) of Panama in 1983 to that in 1986?
Provide a short and direct response. 1.35. What is the ratio of the Emissions(kt) in Iceland in 1983 to that in 1987?
Your response must be concise. 0.85. What is the ratio of the Emissions(kt) of Netherlands in 1983 to that in 1987?
Offer a terse response. 0.88. What is the ratio of the Emissions(kt) in Panama in 1983 to that in 1987?
Your answer should be compact. 1.17. What is the ratio of the Emissions(kt) of Iceland in 1984 to that in 1985?
Your answer should be compact. 1.15. What is the ratio of the Emissions(kt) in Netherlands in 1984 to that in 1985?
Provide a short and direct response. 1.01. What is the ratio of the Emissions(kt) of Panama in 1984 to that in 1985?
Give a very brief answer. 1.04. What is the ratio of the Emissions(kt) of Samoa in 1984 to that in 1985?
Give a very brief answer. 1. What is the ratio of the Emissions(kt) of Iceland in 1984 to that in 1986?
Ensure brevity in your answer.  1.05. What is the ratio of the Emissions(kt) of Netherlands in 1984 to that in 1986?
Make the answer very short. 0.9. What is the ratio of the Emissions(kt) of Panama in 1984 to that in 1986?
Ensure brevity in your answer.  1.1. What is the ratio of the Emissions(kt) in Iceland in 1984 to that in 1987?
Give a very brief answer. 0.97. What is the ratio of the Emissions(kt) in Netherlands in 1984 to that in 1987?
Give a very brief answer. 0.85. What is the ratio of the Emissions(kt) in Panama in 1984 to that in 1987?
Give a very brief answer. 0.95. What is the ratio of the Emissions(kt) in Samoa in 1984 to that in 1987?
Offer a very short reply. 1. What is the ratio of the Emissions(kt) of Iceland in 1985 to that in 1986?
Offer a terse response. 0.91. What is the ratio of the Emissions(kt) of Netherlands in 1985 to that in 1986?
Your answer should be very brief. 0.89. What is the ratio of the Emissions(kt) of Panama in 1985 to that in 1986?
Give a very brief answer. 1.05. What is the ratio of the Emissions(kt) of Samoa in 1985 to that in 1986?
Provide a short and direct response. 1. What is the ratio of the Emissions(kt) of Iceland in 1985 to that in 1987?
Ensure brevity in your answer.  0.85. What is the ratio of the Emissions(kt) of Netherlands in 1985 to that in 1987?
Your response must be concise. 0.84. What is the ratio of the Emissions(kt) in Panama in 1985 to that in 1987?
Your answer should be very brief. 0.91. What is the ratio of the Emissions(kt) in Samoa in 1985 to that in 1987?
Keep it short and to the point. 1. What is the ratio of the Emissions(kt) of Iceland in 1986 to that in 1987?
Your answer should be compact. 0.93. What is the ratio of the Emissions(kt) in Netherlands in 1986 to that in 1987?
Provide a succinct answer. 0.94. What is the ratio of the Emissions(kt) of Panama in 1986 to that in 1987?
Keep it short and to the point. 0.87. What is the ratio of the Emissions(kt) in Samoa in 1986 to that in 1987?
Your response must be concise. 1. What is the difference between the highest and the second highest Emissions(kt) in Iceland?
Your response must be concise. 14.67. What is the difference between the highest and the second highest Emissions(kt) in Netherlands?
Give a very brief answer. 9820.23. What is the difference between the highest and the second highest Emissions(kt) of Panama?
Provide a succinct answer. 216.35. What is the difference between the highest and the second highest Emissions(kt) of Samoa?
Ensure brevity in your answer.  0. What is the difference between the highest and the lowest Emissions(kt) in Iceland?
Provide a succinct answer. 256.69. What is the difference between the highest and the lowest Emissions(kt) in Netherlands?
Your response must be concise. 2.00e+04. What is the difference between the highest and the lowest Emissions(kt) of Panama?
Keep it short and to the point. 861.75. What is the difference between the highest and the lowest Emissions(kt) of Samoa?
Your answer should be compact. 11. 